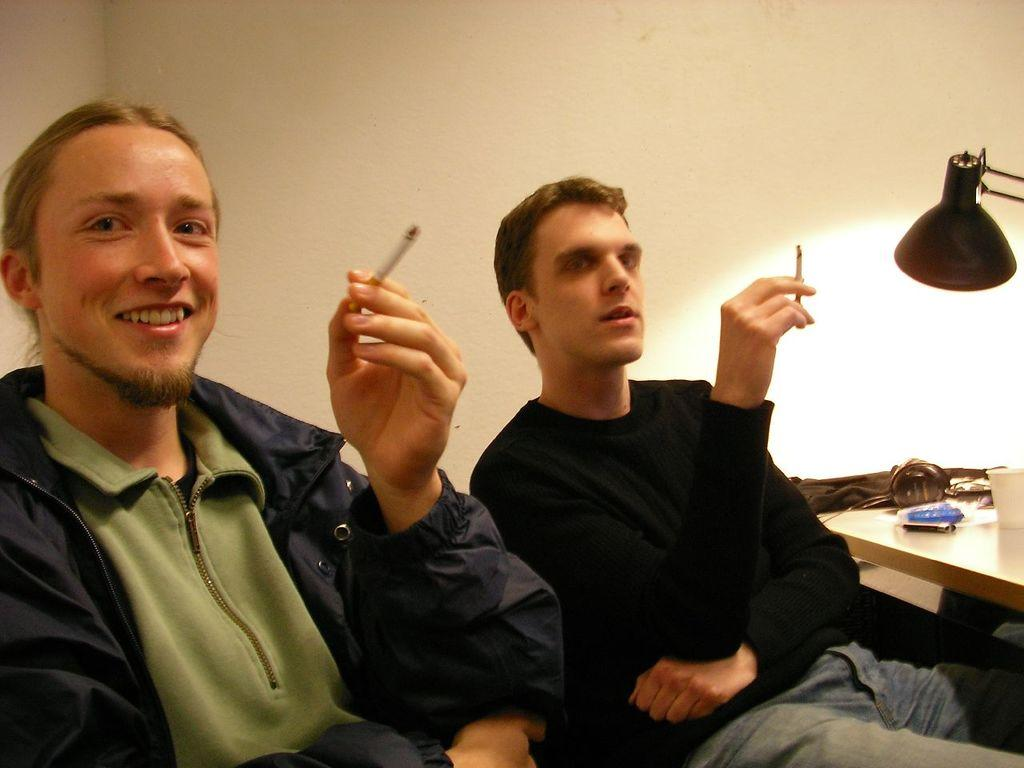What piece of furniture is located on the right side of the image? There is a table on the right side of the image. What can be found on the table? There is a glass and a cloth on the table. What is the source of light in the image? There is light on the right side of the image. How many people are in the image? There are two persons in the middle of the image. What are the two persons holding? The two persons are holding cigarettes. What brand of toothpaste is being used by the grandfather in the image? There is no grandfather or toothpaste present in the image. What event is taking place in the image? The provided facts do not indicate any specific event occurring in the image. 